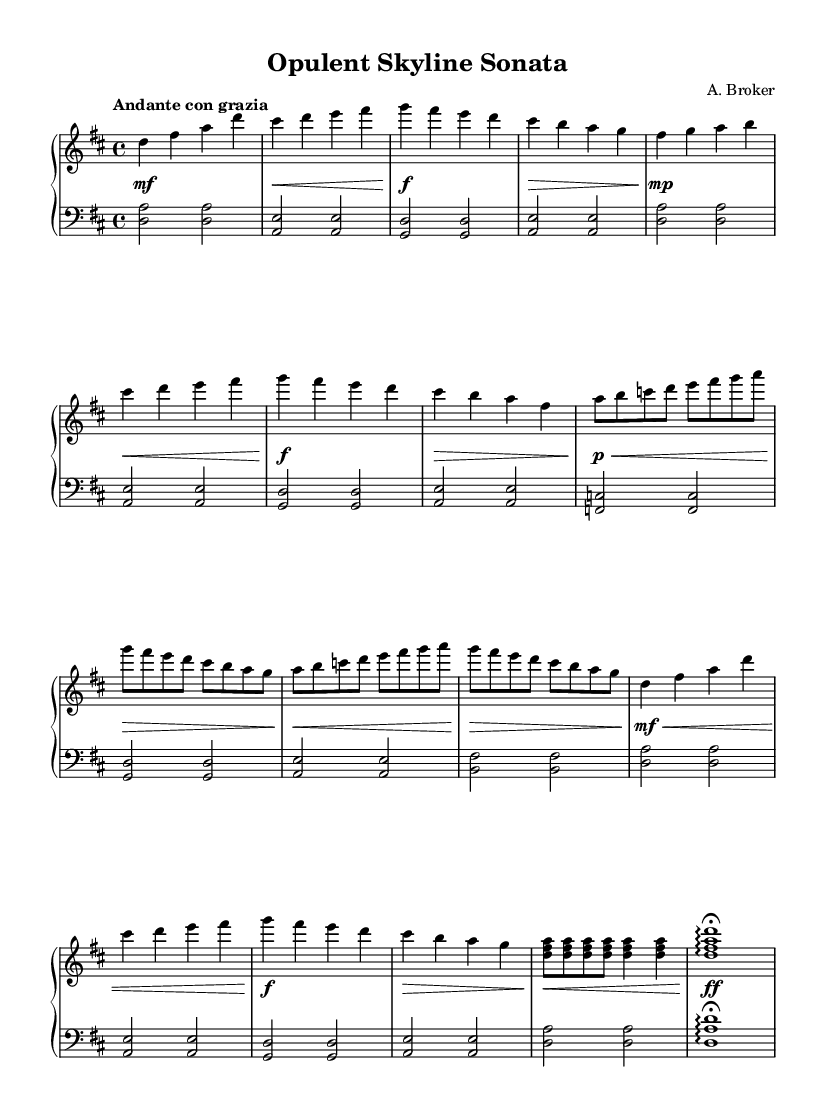What is the key signature of this music? The key signature is indicated at the beginning of the staff. It shows two sharps, which corresponds to D major.
Answer: D major What is the time signature? The time signature appears at the beginning of the score, denoting the number of beats per measure. Here, it is 4/4, meaning four beats per measure with a quarter note receiving one beat.
Answer: 4/4 What is the tempo marking? The tempo marking is clearly written above the staff and indicates the speed at which the piece should be played. It reads "Andante con grazia," which suggests a moderately slow tempo with stylish elegance.
Answer: Andante con grazia How many main themes are present in this piece? By analyzing the structure of the piece, we can see that there is a main theme presented initially followed by a secondary theme. There is a recapitulation of the main theme later, indicating that the main theme appears twice.
Answer: Two What is the final chord of the composition? To determine the final chord, we look at the last measures of the staff where the piece concludes. The last measure shows a D major arpeggio chord, which is indicative of the piece's resolution.
Answer: D major What is the dynamic marking at the beginning of the piece? The dynamic marking is usually indicated at the start of the score, and it typically conveys the intended loudness of the music. In this case, it starts with a mezzo-forte (mf) marking, which means moderately loud.
Answer: mezzo-forte What is the overall mood conveyed through the music? The overall mood can be analyzed by observing the tempo markings as well as the dynamics throughout the piece. The combination of "Andante con grazia" and various dynamic changes suggests a romantic and elegant character.
Answer: Romantic elegance 